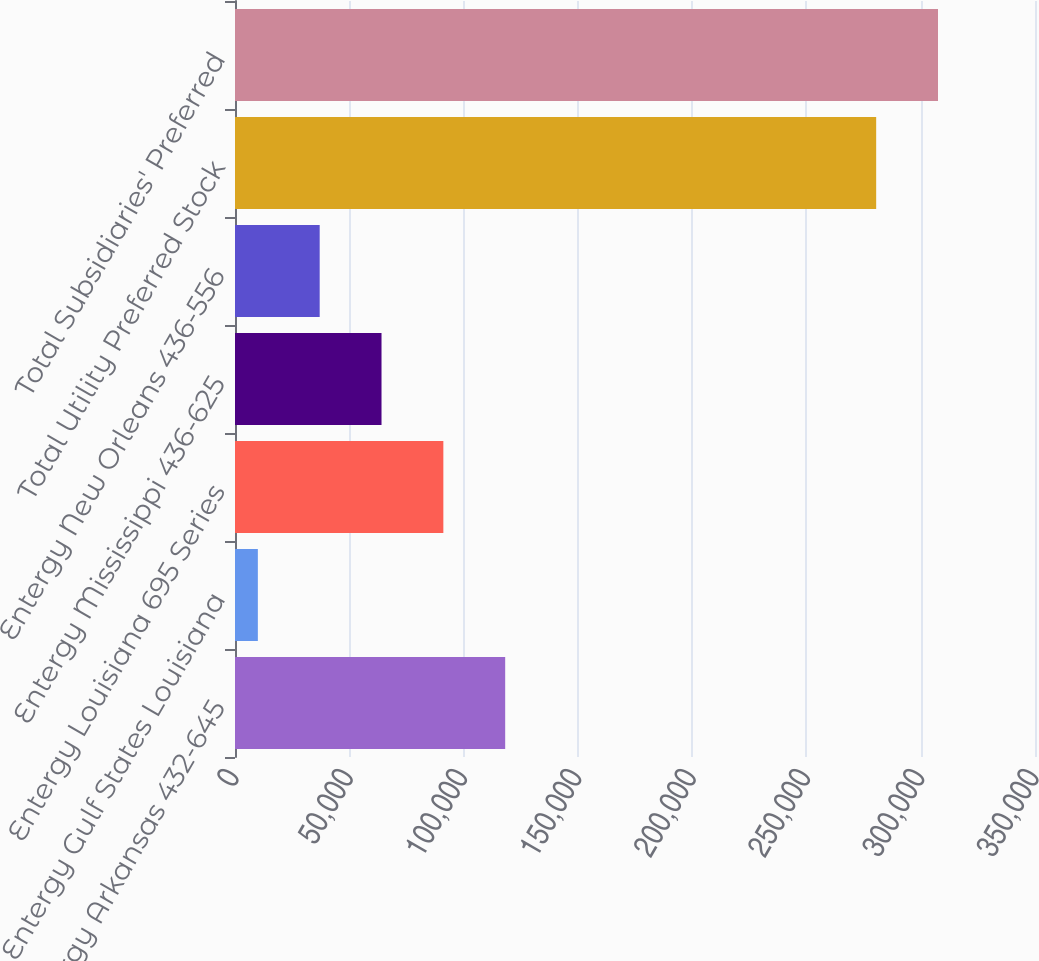<chart> <loc_0><loc_0><loc_500><loc_500><bar_chart><fcel>Entergy Arkansas 432-645<fcel>Entergy Gulf States Louisiana<fcel>Entergy Louisiana 695 Series<fcel>Entergy Mississippi 436-625<fcel>Entergy New Orleans 436-556<fcel>Total Utility Preferred Stock<fcel>Total Subsidiaries' Preferred<nl><fcel>118204<fcel>10000<fcel>91153.3<fcel>64102.2<fcel>37051.1<fcel>280511<fcel>307562<nl></chart> 